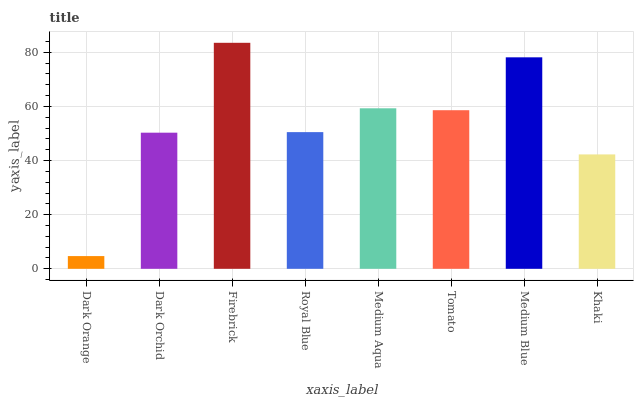Is Dark Orchid the minimum?
Answer yes or no. No. Is Dark Orchid the maximum?
Answer yes or no. No. Is Dark Orchid greater than Dark Orange?
Answer yes or no. Yes. Is Dark Orange less than Dark Orchid?
Answer yes or no. Yes. Is Dark Orange greater than Dark Orchid?
Answer yes or no. No. Is Dark Orchid less than Dark Orange?
Answer yes or no. No. Is Tomato the high median?
Answer yes or no. Yes. Is Royal Blue the low median?
Answer yes or no. Yes. Is Dark Orchid the high median?
Answer yes or no. No. Is Medium Blue the low median?
Answer yes or no. No. 